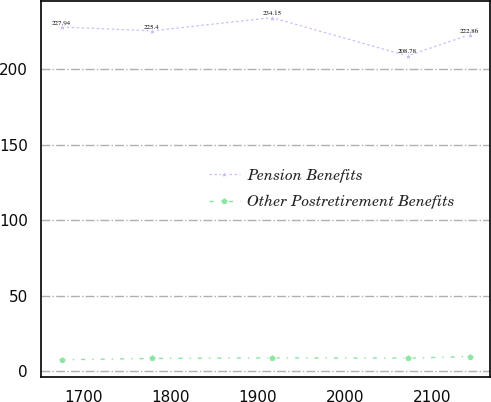Convert chart. <chart><loc_0><loc_0><loc_500><loc_500><line_chart><ecel><fcel>Pension Benefits<fcel>Other Postretirement Benefits<nl><fcel>1675.11<fcel>227.94<fcel>7.45<nl><fcel>1778.8<fcel>225.4<fcel>8.31<nl><fcel>1916.42<fcel>234.15<fcel>8.73<nl><fcel>2071.74<fcel>208.78<fcel>8.52<nl><fcel>2142.95<fcel>222.86<fcel>9.56<nl></chart> 